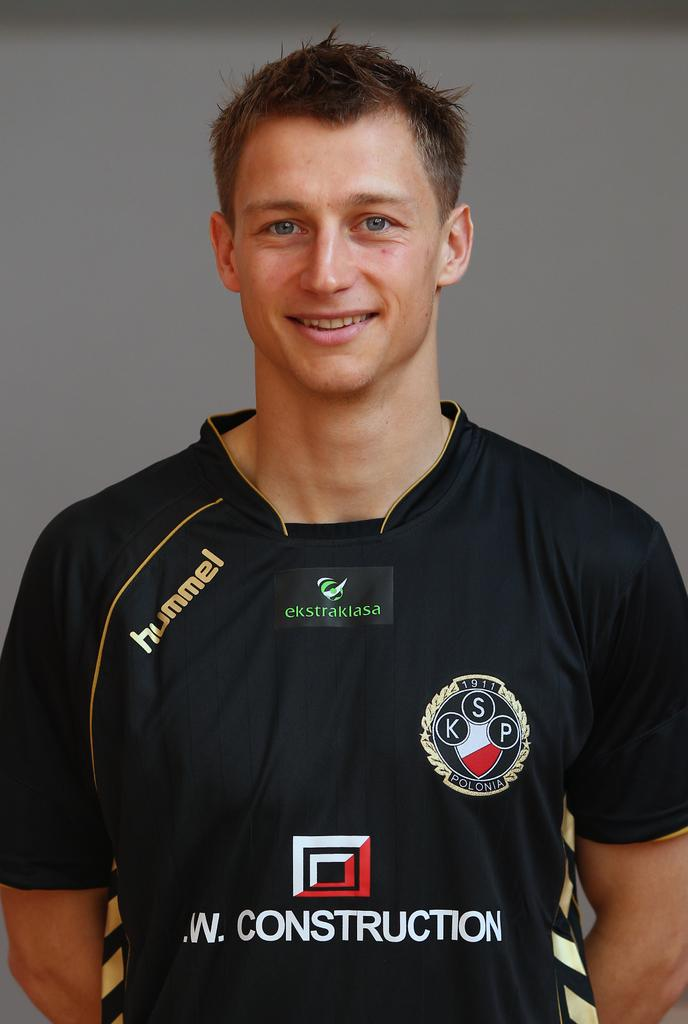Provide a one-sentence caption for the provided image. Man with a black shirt that has the word hummel in gold. 